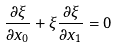<formula> <loc_0><loc_0><loc_500><loc_500>\frac { \partial \xi } { \partial x _ { 0 } } + \xi \frac { \partial \xi } { \partial x _ { 1 } } = 0</formula> 